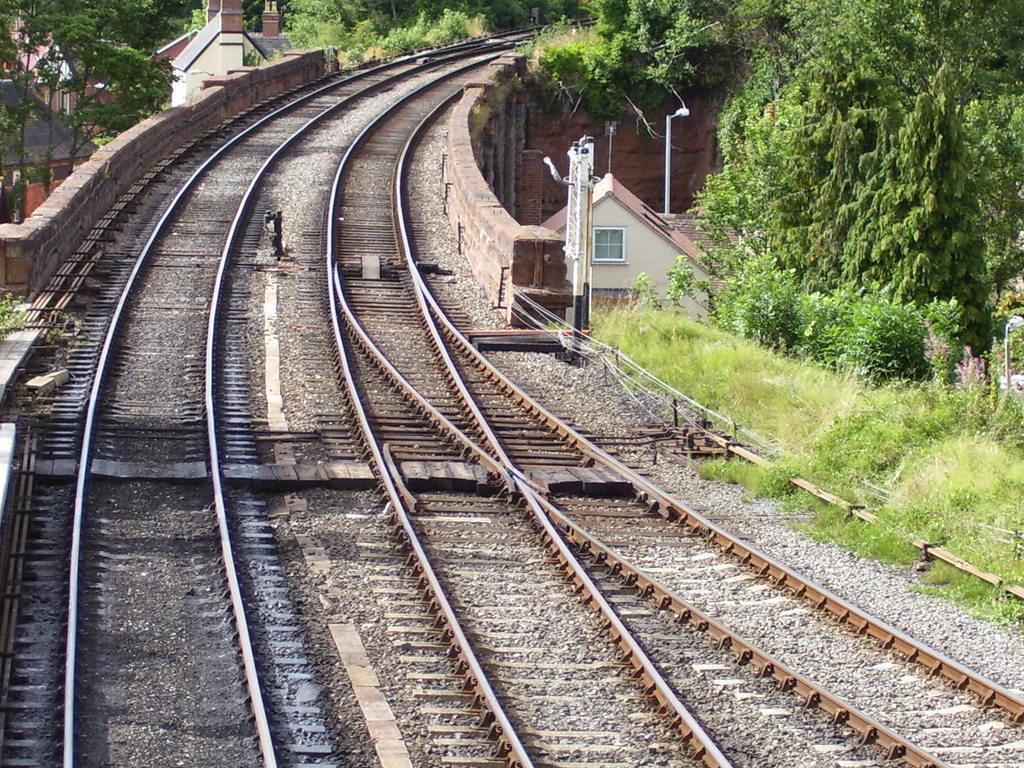Please provide a concise description of this image. In this image we can see that there are two railway tracks one beside the other. In between the tracks there are stones. There are trees beside the tracks and there are houses in between the trees. 